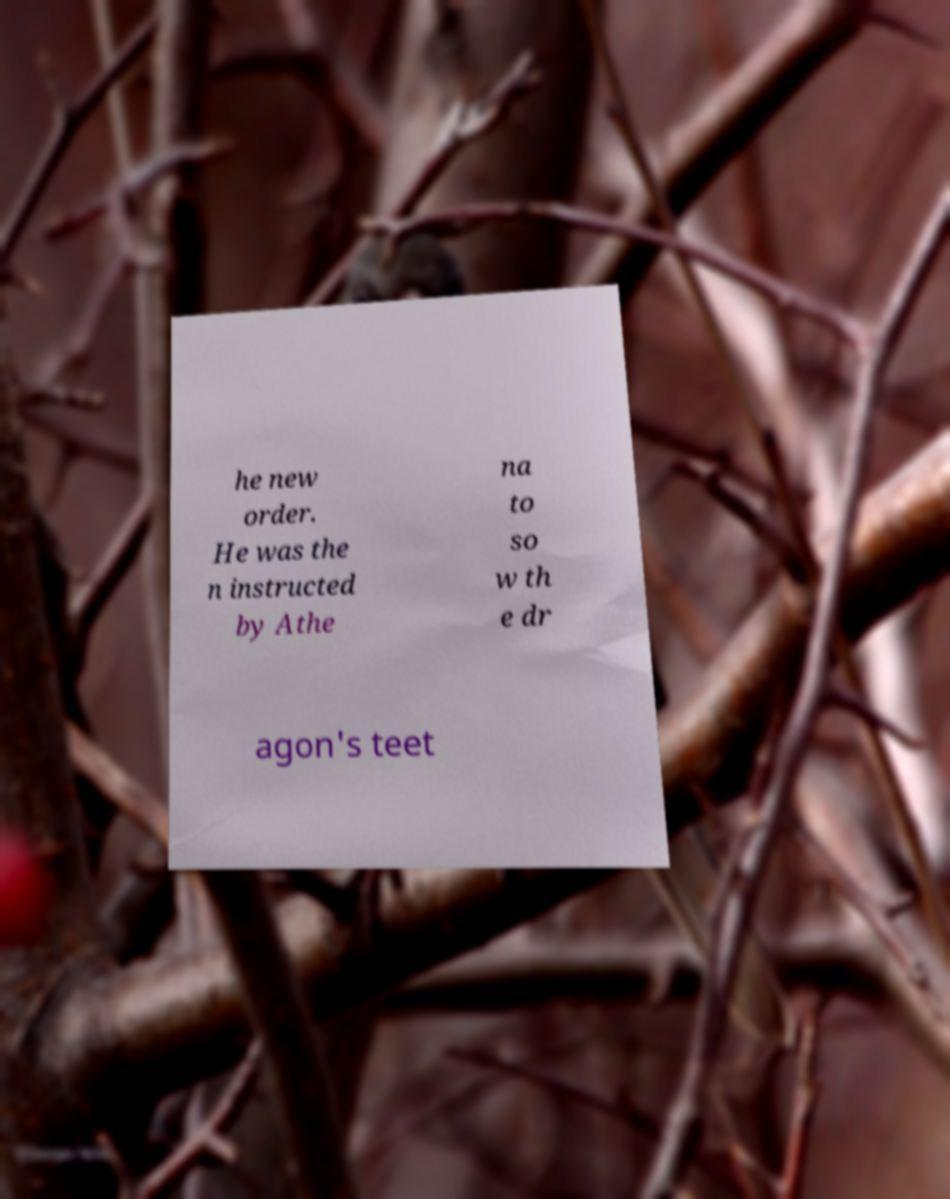I need the written content from this picture converted into text. Can you do that? he new order. He was the n instructed by Athe na to so w th e dr agon's teet 